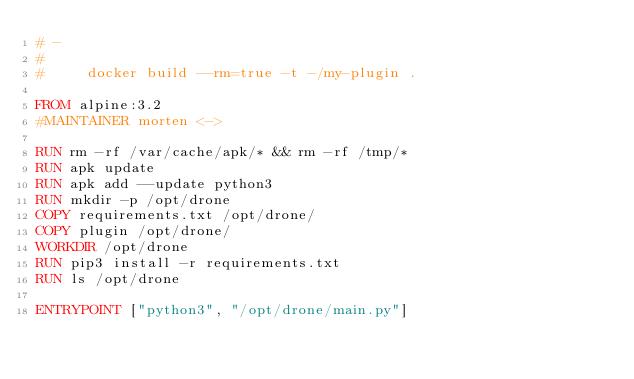Convert code to text. <code><loc_0><loc_0><loc_500><loc_500><_Dockerfile_># -
#
#     docker build --rm=true -t -/my-plugin .

FROM alpine:3.2
#MAINTAINER morten <->

RUN rm -rf /var/cache/apk/* && rm -rf /tmp/*
RUN apk update
RUN apk add --update python3
RUN mkdir -p /opt/drone
COPY requirements.txt /opt/drone/
COPY plugin /opt/drone/
WORKDIR /opt/drone
RUN pip3 install -r requirements.txt
RUN ls /opt/drone

ENTRYPOINT ["python3", "/opt/drone/main.py"]
</code> 